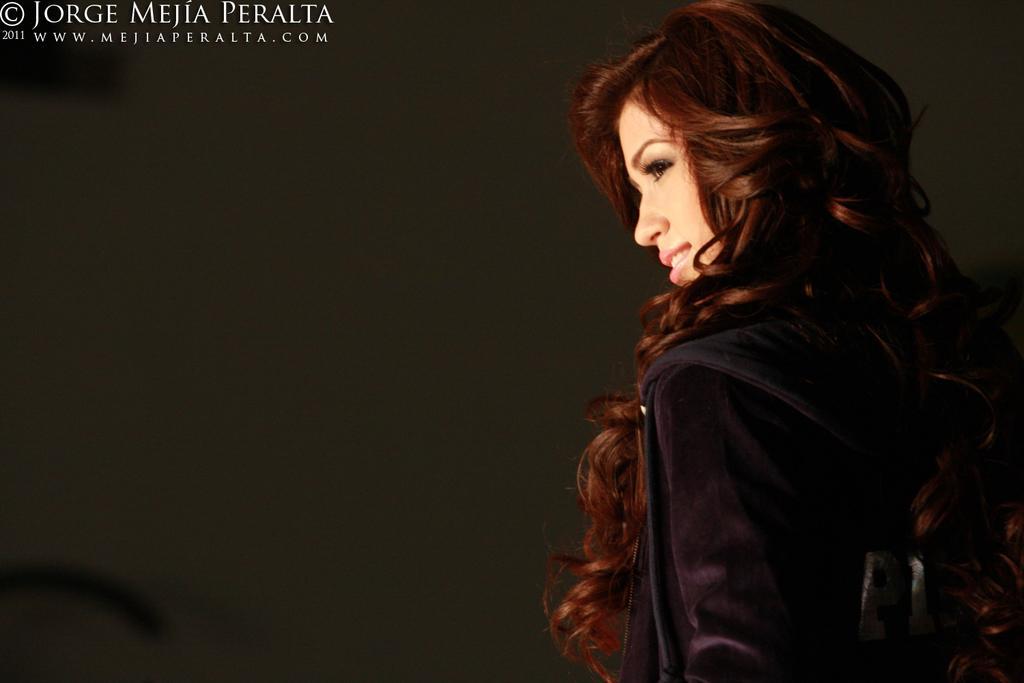How would you summarize this image in a sentence or two? On the right side of the image there is a woman. At the top left corner there is text. 